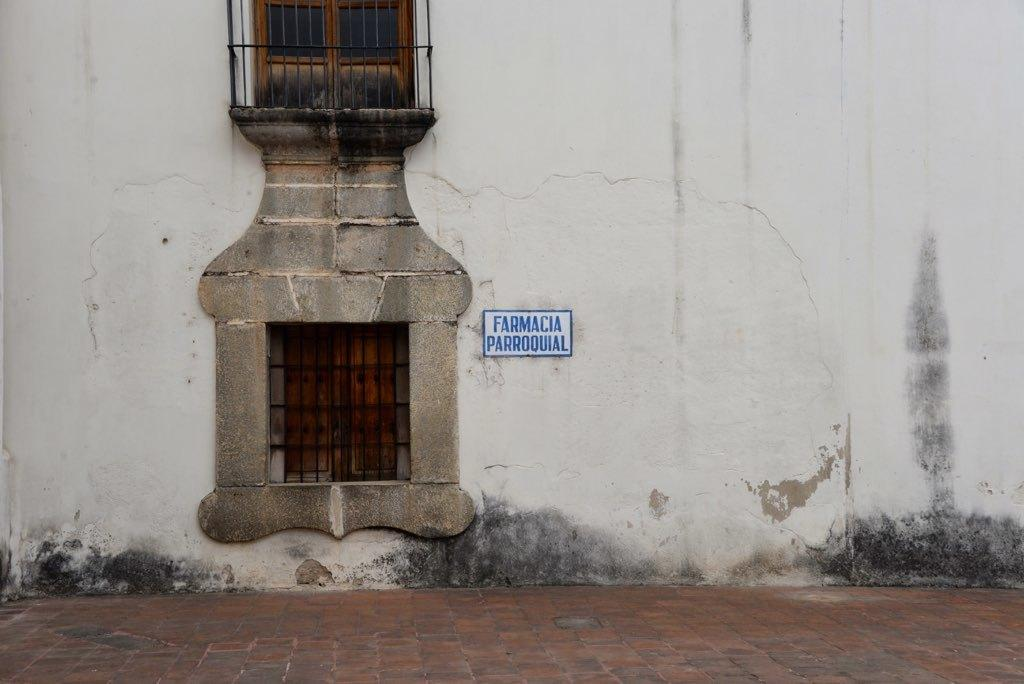How many windows are visible on the wall in the image? There are two windows on the wall in the image. What is located in front of the windows? There is a footpath in front of the windows. What type of list can be seen hanging on the wall near the windows? There is no list present in the image; only the windows and footpath are visible. 